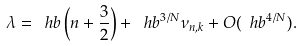Convert formula to latex. <formula><loc_0><loc_0><loc_500><loc_500>\lambda = \ h b \left ( n + \frac { 3 } { 2 } \right ) + \ h b ^ { 3 / N } \nu _ { n , k } + O ( \ h b ^ { 4 / N } ) .</formula> 